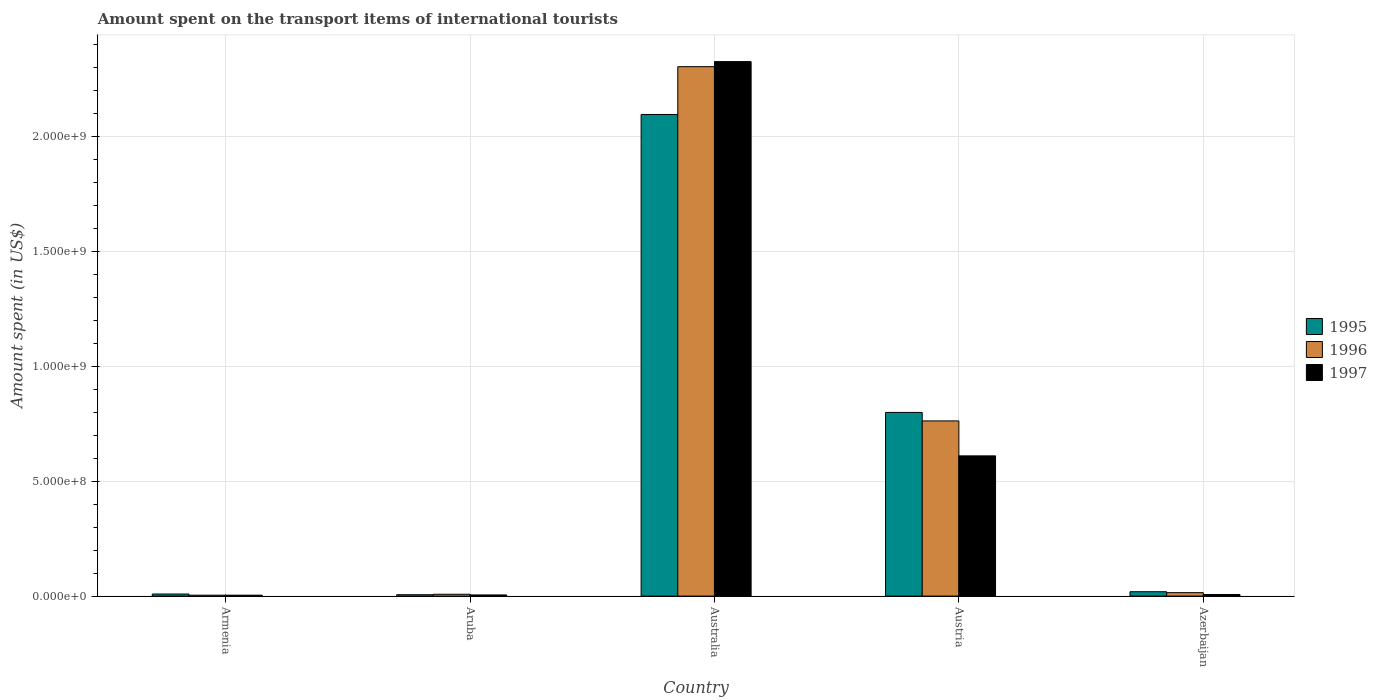How many different coloured bars are there?
Your answer should be compact. 3. How many groups of bars are there?
Provide a short and direct response. 5. Are the number of bars per tick equal to the number of legend labels?
Provide a succinct answer. Yes. Are the number of bars on each tick of the X-axis equal?
Your answer should be compact. Yes. How many bars are there on the 5th tick from the right?
Ensure brevity in your answer.  3. What is the label of the 2nd group of bars from the left?
Give a very brief answer. Aruba. Across all countries, what is the maximum amount spent on the transport items of international tourists in 1996?
Keep it short and to the point. 2.30e+09. In which country was the amount spent on the transport items of international tourists in 1996 minimum?
Give a very brief answer. Armenia. What is the total amount spent on the transport items of international tourists in 1997 in the graph?
Provide a short and direct response. 2.95e+09. What is the difference between the amount spent on the transport items of international tourists in 1995 in Armenia and that in Australia?
Give a very brief answer. -2.09e+09. What is the difference between the amount spent on the transport items of international tourists in 1996 in Australia and the amount spent on the transport items of international tourists in 1997 in Armenia?
Make the answer very short. 2.30e+09. What is the average amount spent on the transport items of international tourists in 1996 per country?
Your answer should be very brief. 6.18e+08. What is the difference between the amount spent on the transport items of international tourists of/in 1995 and amount spent on the transport items of international tourists of/in 1997 in Austria?
Offer a terse response. 1.89e+08. What is the ratio of the amount spent on the transport items of international tourists in 1995 in Armenia to that in Austria?
Your answer should be very brief. 0.01. Is the amount spent on the transport items of international tourists in 1995 in Armenia less than that in Austria?
Keep it short and to the point. Yes. What is the difference between the highest and the second highest amount spent on the transport items of international tourists in 1995?
Your answer should be compact. 2.08e+09. What is the difference between the highest and the lowest amount spent on the transport items of international tourists in 1997?
Provide a succinct answer. 2.32e+09. In how many countries, is the amount spent on the transport items of international tourists in 1995 greater than the average amount spent on the transport items of international tourists in 1995 taken over all countries?
Offer a very short reply. 2. Is the sum of the amount spent on the transport items of international tourists in 1996 in Austria and Azerbaijan greater than the maximum amount spent on the transport items of international tourists in 1997 across all countries?
Provide a short and direct response. No. What does the 1st bar from the left in Azerbaijan represents?
Your answer should be very brief. 1995. What does the 2nd bar from the right in Aruba represents?
Ensure brevity in your answer.  1996. Are all the bars in the graph horizontal?
Offer a very short reply. No. Are the values on the major ticks of Y-axis written in scientific E-notation?
Offer a terse response. Yes. Where does the legend appear in the graph?
Offer a very short reply. Center right. What is the title of the graph?
Make the answer very short. Amount spent on the transport items of international tourists. Does "1982" appear as one of the legend labels in the graph?
Make the answer very short. No. What is the label or title of the Y-axis?
Ensure brevity in your answer.  Amount spent (in US$). What is the Amount spent (in US$) of 1995 in Armenia?
Provide a short and direct response. 9.00e+06. What is the Amount spent (in US$) of 1997 in Armenia?
Provide a short and direct response. 4.00e+06. What is the Amount spent (in US$) of 1997 in Aruba?
Your response must be concise. 5.00e+06. What is the Amount spent (in US$) in 1995 in Australia?
Provide a short and direct response. 2.10e+09. What is the Amount spent (in US$) of 1996 in Australia?
Make the answer very short. 2.30e+09. What is the Amount spent (in US$) of 1997 in Australia?
Keep it short and to the point. 2.32e+09. What is the Amount spent (in US$) in 1995 in Austria?
Keep it short and to the point. 7.99e+08. What is the Amount spent (in US$) of 1996 in Austria?
Make the answer very short. 7.62e+08. What is the Amount spent (in US$) of 1997 in Austria?
Your answer should be very brief. 6.10e+08. What is the Amount spent (in US$) of 1995 in Azerbaijan?
Your answer should be compact. 1.90e+07. What is the Amount spent (in US$) in 1996 in Azerbaijan?
Your answer should be very brief. 1.50e+07. What is the Amount spent (in US$) of 1997 in Azerbaijan?
Give a very brief answer. 7.00e+06. Across all countries, what is the maximum Amount spent (in US$) of 1995?
Your answer should be very brief. 2.10e+09. Across all countries, what is the maximum Amount spent (in US$) of 1996?
Give a very brief answer. 2.30e+09. Across all countries, what is the maximum Amount spent (in US$) in 1997?
Your answer should be compact. 2.32e+09. What is the total Amount spent (in US$) in 1995 in the graph?
Offer a terse response. 2.93e+09. What is the total Amount spent (in US$) of 1996 in the graph?
Make the answer very short. 3.09e+09. What is the total Amount spent (in US$) in 1997 in the graph?
Your answer should be very brief. 2.95e+09. What is the difference between the Amount spent (in US$) of 1995 in Armenia and that in Aruba?
Ensure brevity in your answer.  3.00e+06. What is the difference between the Amount spent (in US$) in 1996 in Armenia and that in Aruba?
Your response must be concise. -4.00e+06. What is the difference between the Amount spent (in US$) of 1997 in Armenia and that in Aruba?
Offer a terse response. -1.00e+06. What is the difference between the Amount spent (in US$) of 1995 in Armenia and that in Australia?
Provide a succinct answer. -2.09e+09. What is the difference between the Amount spent (in US$) of 1996 in Armenia and that in Australia?
Offer a terse response. -2.30e+09. What is the difference between the Amount spent (in US$) of 1997 in Armenia and that in Australia?
Give a very brief answer. -2.32e+09. What is the difference between the Amount spent (in US$) in 1995 in Armenia and that in Austria?
Your answer should be very brief. -7.90e+08. What is the difference between the Amount spent (in US$) in 1996 in Armenia and that in Austria?
Keep it short and to the point. -7.58e+08. What is the difference between the Amount spent (in US$) of 1997 in Armenia and that in Austria?
Provide a short and direct response. -6.06e+08. What is the difference between the Amount spent (in US$) of 1995 in Armenia and that in Azerbaijan?
Your answer should be very brief. -1.00e+07. What is the difference between the Amount spent (in US$) of 1996 in Armenia and that in Azerbaijan?
Your answer should be compact. -1.10e+07. What is the difference between the Amount spent (in US$) of 1995 in Aruba and that in Australia?
Provide a short and direct response. -2.09e+09. What is the difference between the Amount spent (in US$) in 1996 in Aruba and that in Australia?
Give a very brief answer. -2.30e+09. What is the difference between the Amount spent (in US$) of 1997 in Aruba and that in Australia?
Make the answer very short. -2.32e+09. What is the difference between the Amount spent (in US$) in 1995 in Aruba and that in Austria?
Your answer should be compact. -7.93e+08. What is the difference between the Amount spent (in US$) of 1996 in Aruba and that in Austria?
Offer a very short reply. -7.54e+08. What is the difference between the Amount spent (in US$) in 1997 in Aruba and that in Austria?
Offer a terse response. -6.05e+08. What is the difference between the Amount spent (in US$) in 1995 in Aruba and that in Azerbaijan?
Provide a succinct answer. -1.30e+07. What is the difference between the Amount spent (in US$) of 1996 in Aruba and that in Azerbaijan?
Ensure brevity in your answer.  -7.00e+06. What is the difference between the Amount spent (in US$) in 1995 in Australia and that in Austria?
Your answer should be very brief. 1.30e+09. What is the difference between the Amount spent (in US$) of 1996 in Australia and that in Austria?
Keep it short and to the point. 1.54e+09. What is the difference between the Amount spent (in US$) of 1997 in Australia and that in Austria?
Your answer should be very brief. 1.72e+09. What is the difference between the Amount spent (in US$) in 1995 in Australia and that in Azerbaijan?
Provide a succinct answer. 2.08e+09. What is the difference between the Amount spent (in US$) in 1996 in Australia and that in Azerbaijan?
Your answer should be very brief. 2.29e+09. What is the difference between the Amount spent (in US$) of 1997 in Australia and that in Azerbaijan?
Your response must be concise. 2.32e+09. What is the difference between the Amount spent (in US$) of 1995 in Austria and that in Azerbaijan?
Offer a terse response. 7.80e+08. What is the difference between the Amount spent (in US$) in 1996 in Austria and that in Azerbaijan?
Your response must be concise. 7.47e+08. What is the difference between the Amount spent (in US$) in 1997 in Austria and that in Azerbaijan?
Make the answer very short. 6.03e+08. What is the difference between the Amount spent (in US$) in 1995 in Armenia and the Amount spent (in US$) in 1997 in Aruba?
Provide a succinct answer. 4.00e+06. What is the difference between the Amount spent (in US$) in 1995 in Armenia and the Amount spent (in US$) in 1996 in Australia?
Keep it short and to the point. -2.29e+09. What is the difference between the Amount spent (in US$) in 1995 in Armenia and the Amount spent (in US$) in 1997 in Australia?
Provide a succinct answer. -2.32e+09. What is the difference between the Amount spent (in US$) of 1996 in Armenia and the Amount spent (in US$) of 1997 in Australia?
Offer a terse response. -2.32e+09. What is the difference between the Amount spent (in US$) in 1995 in Armenia and the Amount spent (in US$) in 1996 in Austria?
Your answer should be very brief. -7.53e+08. What is the difference between the Amount spent (in US$) in 1995 in Armenia and the Amount spent (in US$) in 1997 in Austria?
Offer a very short reply. -6.01e+08. What is the difference between the Amount spent (in US$) of 1996 in Armenia and the Amount spent (in US$) of 1997 in Austria?
Provide a short and direct response. -6.06e+08. What is the difference between the Amount spent (in US$) of 1995 in Armenia and the Amount spent (in US$) of 1996 in Azerbaijan?
Make the answer very short. -6.00e+06. What is the difference between the Amount spent (in US$) in 1996 in Armenia and the Amount spent (in US$) in 1997 in Azerbaijan?
Provide a succinct answer. -3.00e+06. What is the difference between the Amount spent (in US$) of 1995 in Aruba and the Amount spent (in US$) of 1996 in Australia?
Provide a short and direct response. -2.30e+09. What is the difference between the Amount spent (in US$) in 1995 in Aruba and the Amount spent (in US$) in 1997 in Australia?
Your response must be concise. -2.32e+09. What is the difference between the Amount spent (in US$) of 1996 in Aruba and the Amount spent (in US$) of 1997 in Australia?
Give a very brief answer. -2.32e+09. What is the difference between the Amount spent (in US$) of 1995 in Aruba and the Amount spent (in US$) of 1996 in Austria?
Offer a very short reply. -7.56e+08. What is the difference between the Amount spent (in US$) of 1995 in Aruba and the Amount spent (in US$) of 1997 in Austria?
Your answer should be very brief. -6.04e+08. What is the difference between the Amount spent (in US$) in 1996 in Aruba and the Amount spent (in US$) in 1997 in Austria?
Provide a succinct answer. -6.02e+08. What is the difference between the Amount spent (in US$) of 1995 in Aruba and the Amount spent (in US$) of 1996 in Azerbaijan?
Ensure brevity in your answer.  -9.00e+06. What is the difference between the Amount spent (in US$) of 1995 in Australia and the Amount spent (in US$) of 1996 in Austria?
Keep it short and to the point. 1.33e+09. What is the difference between the Amount spent (in US$) of 1995 in Australia and the Amount spent (in US$) of 1997 in Austria?
Provide a succinct answer. 1.48e+09. What is the difference between the Amount spent (in US$) of 1996 in Australia and the Amount spent (in US$) of 1997 in Austria?
Provide a succinct answer. 1.69e+09. What is the difference between the Amount spent (in US$) of 1995 in Australia and the Amount spent (in US$) of 1996 in Azerbaijan?
Offer a terse response. 2.08e+09. What is the difference between the Amount spent (in US$) of 1995 in Australia and the Amount spent (in US$) of 1997 in Azerbaijan?
Your response must be concise. 2.09e+09. What is the difference between the Amount spent (in US$) of 1996 in Australia and the Amount spent (in US$) of 1997 in Azerbaijan?
Make the answer very short. 2.30e+09. What is the difference between the Amount spent (in US$) of 1995 in Austria and the Amount spent (in US$) of 1996 in Azerbaijan?
Your answer should be compact. 7.84e+08. What is the difference between the Amount spent (in US$) of 1995 in Austria and the Amount spent (in US$) of 1997 in Azerbaijan?
Provide a short and direct response. 7.92e+08. What is the difference between the Amount spent (in US$) in 1996 in Austria and the Amount spent (in US$) in 1997 in Azerbaijan?
Provide a succinct answer. 7.55e+08. What is the average Amount spent (in US$) of 1995 per country?
Offer a terse response. 5.86e+08. What is the average Amount spent (in US$) in 1996 per country?
Make the answer very short. 6.18e+08. What is the average Amount spent (in US$) in 1997 per country?
Make the answer very short. 5.90e+08. What is the difference between the Amount spent (in US$) of 1995 and Amount spent (in US$) of 1996 in Armenia?
Provide a succinct answer. 5.00e+06. What is the difference between the Amount spent (in US$) of 1995 and Amount spent (in US$) of 1997 in Armenia?
Your response must be concise. 5.00e+06. What is the difference between the Amount spent (in US$) of 1996 and Amount spent (in US$) of 1997 in Armenia?
Keep it short and to the point. 0. What is the difference between the Amount spent (in US$) in 1995 and Amount spent (in US$) in 1996 in Aruba?
Provide a short and direct response. -2.00e+06. What is the difference between the Amount spent (in US$) in 1995 and Amount spent (in US$) in 1996 in Australia?
Provide a short and direct response. -2.08e+08. What is the difference between the Amount spent (in US$) in 1995 and Amount spent (in US$) in 1997 in Australia?
Make the answer very short. -2.30e+08. What is the difference between the Amount spent (in US$) in 1996 and Amount spent (in US$) in 1997 in Australia?
Keep it short and to the point. -2.20e+07. What is the difference between the Amount spent (in US$) in 1995 and Amount spent (in US$) in 1996 in Austria?
Offer a terse response. 3.70e+07. What is the difference between the Amount spent (in US$) of 1995 and Amount spent (in US$) of 1997 in Austria?
Give a very brief answer. 1.89e+08. What is the difference between the Amount spent (in US$) in 1996 and Amount spent (in US$) in 1997 in Austria?
Make the answer very short. 1.52e+08. What is the ratio of the Amount spent (in US$) in 1996 in Armenia to that in Aruba?
Offer a terse response. 0.5. What is the ratio of the Amount spent (in US$) in 1997 in Armenia to that in Aruba?
Offer a very short reply. 0.8. What is the ratio of the Amount spent (in US$) of 1995 in Armenia to that in Australia?
Offer a very short reply. 0. What is the ratio of the Amount spent (in US$) of 1996 in Armenia to that in Australia?
Offer a very short reply. 0. What is the ratio of the Amount spent (in US$) in 1997 in Armenia to that in Australia?
Give a very brief answer. 0. What is the ratio of the Amount spent (in US$) of 1995 in Armenia to that in Austria?
Your response must be concise. 0.01. What is the ratio of the Amount spent (in US$) of 1996 in Armenia to that in Austria?
Your response must be concise. 0.01. What is the ratio of the Amount spent (in US$) in 1997 in Armenia to that in Austria?
Provide a succinct answer. 0.01. What is the ratio of the Amount spent (in US$) of 1995 in Armenia to that in Azerbaijan?
Offer a terse response. 0.47. What is the ratio of the Amount spent (in US$) of 1996 in Armenia to that in Azerbaijan?
Your answer should be very brief. 0.27. What is the ratio of the Amount spent (in US$) of 1997 in Armenia to that in Azerbaijan?
Offer a very short reply. 0.57. What is the ratio of the Amount spent (in US$) in 1995 in Aruba to that in Australia?
Your response must be concise. 0. What is the ratio of the Amount spent (in US$) of 1996 in Aruba to that in Australia?
Offer a terse response. 0. What is the ratio of the Amount spent (in US$) in 1997 in Aruba to that in Australia?
Offer a very short reply. 0. What is the ratio of the Amount spent (in US$) in 1995 in Aruba to that in Austria?
Your response must be concise. 0.01. What is the ratio of the Amount spent (in US$) in 1996 in Aruba to that in Austria?
Keep it short and to the point. 0.01. What is the ratio of the Amount spent (in US$) of 1997 in Aruba to that in Austria?
Give a very brief answer. 0.01. What is the ratio of the Amount spent (in US$) of 1995 in Aruba to that in Azerbaijan?
Your response must be concise. 0.32. What is the ratio of the Amount spent (in US$) in 1996 in Aruba to that in Azerbaijan?
Your answer should be very brief. 0.53. What is the ratio of the Amount spent (in US$) in 1997 in Aruba to that in Azerbaijan?
Give a very brief answer. 0.71. What is the ratio of the Amount spent (in US$) of 1995 in Australia to that in Austria?
Provide a succinct answer. 2.62. What is the ratio of the Amount spent (in US$) in 1996 in Australia to that in Austria?
Keep it short and to the point. 3.02. What is the ratio of the Amount spent (in US$) of 1997 in Australia to that in Austria?
Your response must be concise. 3.81. What is the ratio of the Amount spent (in US$) in 1995 in Australia to that in Azerbaijan?
Your answer should be compact. 110.26. What is the ratio of the Amount spent (in US$) of 1996 in Australia to that in Azerbaijan?
Your answer should be very brief. 153.53. What is the ratio of the Amount spent (in US$) in 1997 in Australia to that in Azerbaijan?
Provide a succinct answer. 332.14. What is the ratio of the Amount spent (in US$) of 1995 in Austria to that in Azerbaijan?
Provide a short and direct response. 42.05. What is the ratio of the Amount spent (in US$) of 1996 in Austria to that in Azerbaijan?
Your response must be concise. 50.8. What is the ratio of the Amount spent (in US$) of 1997 in Austria to that in Azerbaijan?
Offer a very short reply. 87.14. What is the difference between the highest and the second highest Amount spent (in US$) in 1995?
Offer a terse response. 1.30e+09. What is the difference between the highest and the second highest Amount spent (in US$) of 1996?
Offer a very short reply. 1.54e+09. What is the difference between the highest and the second highest Amount spent (in US$) in 1997?
Offer a terse response. 1.72e+09. What is the difference between the highest and the lowest Amount spent (in US$) of 1995?
Keep it short and to the point. 2.09e+09. What is the difference between the highest and the lowest Amount spent (in US$) of 1996?
Your answer should be very brief. 2.30e+09. What is the difference between the highest and the lowest Amount spent (in US$) of 1997?
Offer a very short reply. 2.32e+09. 